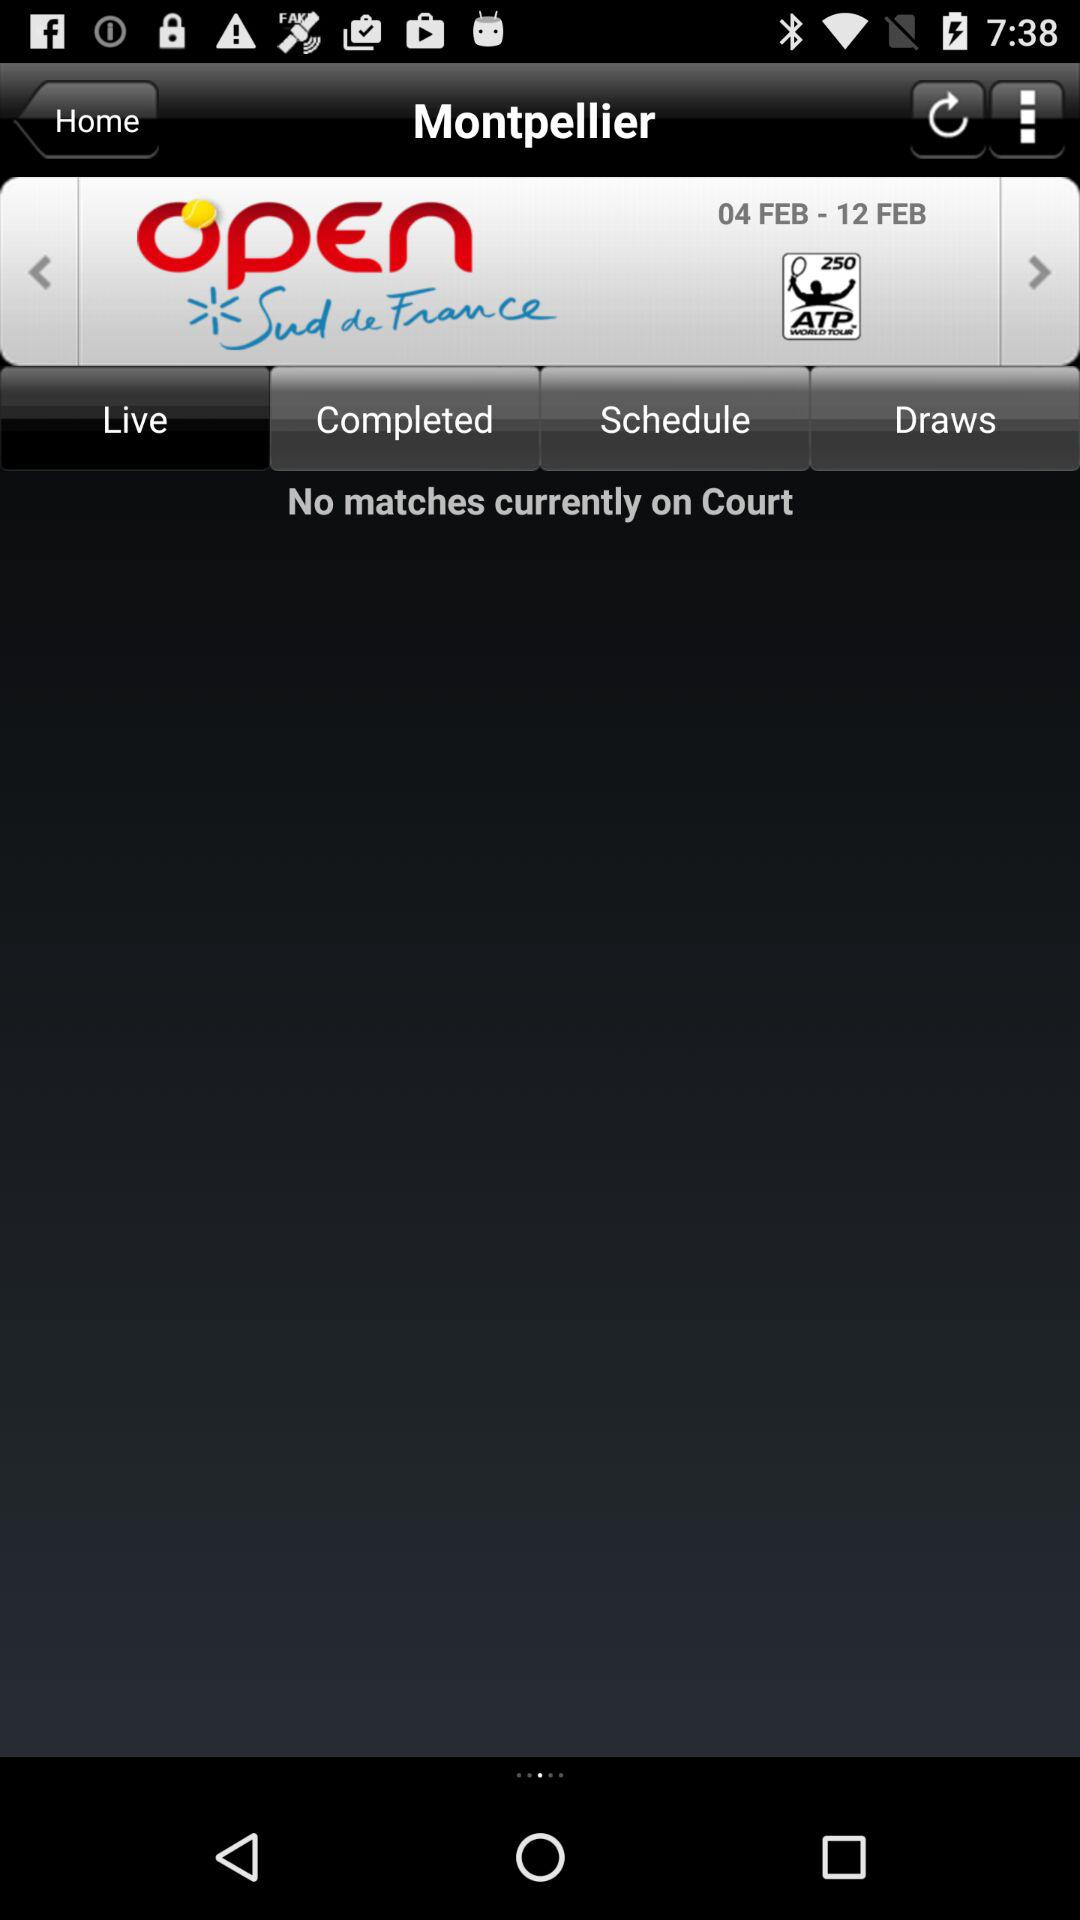What is the name of the application?
When the provided information is insufficient, respond with <no answer>. <no answer> 